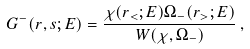<formula> <loc_0><loc_0><loc_500><loc_500>G ^ { - } ( r , s ; E ) = \frac { \chi ( r _ { < } ; E ) \Omega _ { - } ( r _ { > } ; E ) } { W ( \chi , \Omega _ { - } ) } \, ,</formula> 